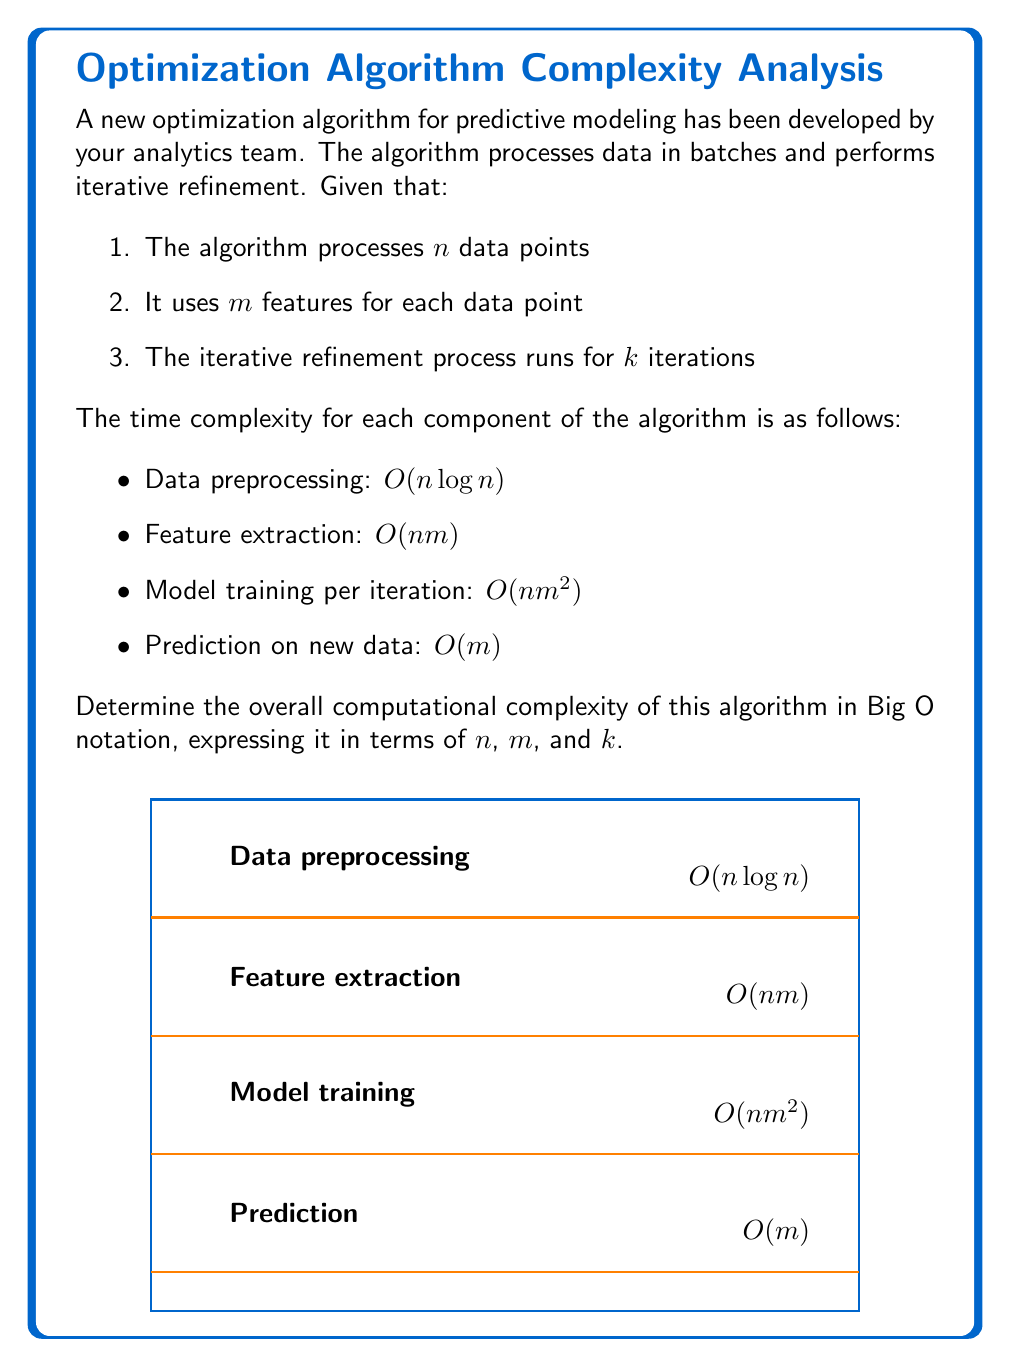What is the answer to this math problem? To determine the overall computational complexity, we need to analyze each component and combine them:

1. Data preprocessing: $O(n \log n)$
   This is performed once for the entire dataset.

2. Feature extraction: $O(nm)$
   This is also performed once for all data points and features.

3. Model training: $O(nm^2)$
   This is performed $k$ times due to the iterative refinement process, so it becomes $O(knm^2)$.

4. Prediction: $O(m)$
   This is typically performed on new data and doesn't affect the training complexity.

To combine these complexities, we add them together:

$$O(n \log n) + O(nm) + O(knm^2) + O(m)$$

We can simplify this by considering the dominant terms:

1. $O(n \log n)$ is dominated by $O(nm)$ when $m > \log n$, which is typically the case in most practical scenarios.
2. $O(nm)$ is dominated by $O(knm^2)$ since $k \geq 1$ and $m \geq 1$.
3. $O(m)$ is insignificant compared to the other terms and can be omitted.

Therefore, the dominant term is $O(knm^2)$, which represents the iterative model training process.
Answer: $O(knm^2)$ 